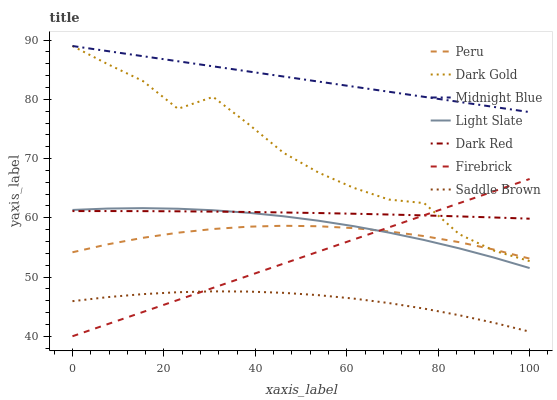Does Saddle Brown have the minimum area under the curve?
Answer yes or no. Yes. Does Midnight Blue have the maximum area under the curve?
Answer yes or no. Yes. Does Dark Gold have the minimum area under the curve?
Answer yes or no. No. Does Dark Gold have the maximum area under the curve?
Answer yes or no. No. Is Midnight Blue the smoothest?
Answer yes or no. Yes. Is Dark Gold the roughest?
Answer yes or no. Yes. Is Light Slate the smoothest?
Answer yes or no. No. Is Light Slate the roughest?
Answer yes or no. No. Does Dark Gold have the lowest value?
Answer yes or no. No. Does Dark Gold have the highest value?
Answer yes or no. Yes. Does Light Slate have the highest value?
Answer yes or no. No. Is Saddle Brown less than Dark Gold?
Answer yes or no. Yes. Is Midnight Blue greater than Dark Red?
Answer yes or no. Yes. Does Dark Gold intersect Firebrick?
Answer yes or no. Yes. Is Dark Gold less than Firebrick?
Answer yes or no. No. Is Dark Gold greater than Firebrick?
Answer yes or no. No. Does Saddle Brown intersect Dark Gold?
Answer yes or no. No. 